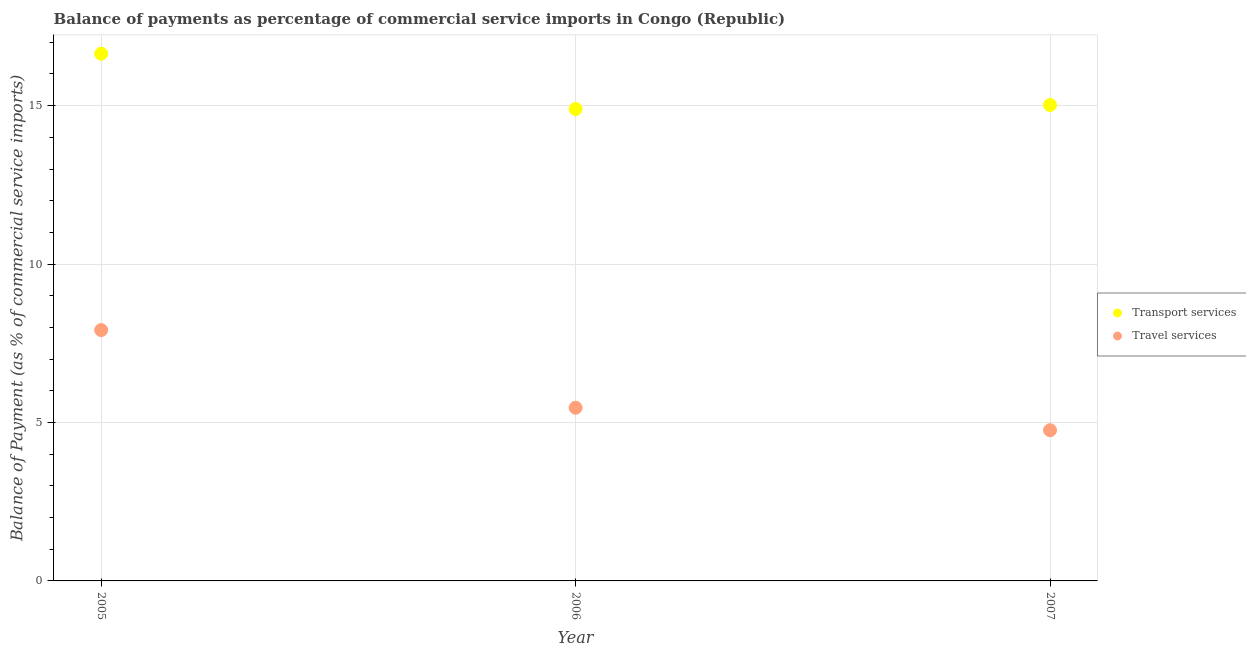What is the balance of payments of travel services in 2005?
Keep it short and to the point. 7.92. Across all years, what is the maximum balance of payments of travel services?
Your response must be concise. 7.92. Across all years, what is the minimum balance of payments of travel services?
Keep it short and to the point. 4.76. In which year was the balance of payments of transport services maximum?
Your response must be concise. 2005. What is the total balance of payments of transport services in the graph?
Ensure brevity in your answer.  46.56. What is the difference between the balance of payments of transport services in 2006 and that in 2007?
Ensure brevity in your answer.  -0.13. What is the difference between the balance of payments of transport services in 2007 and the balance of payments of travel services in 2006?
Offer a terse response. 9.56. What is the average balance of payments of travel services per year?
Give a very brief answer. 6.05. In the year 2007, what is the difference between the balance of payments of travel services and balance of payments of transport services?
Your response must be concise. -10.26. What is the ratio of the balance of payments of transport services in 2005 to that in 2006?
Make the answer very short. 1.12. Is the balance of payments of transport services in 2006 less than that in 2007?
Your answer should be compact. Yes. Is the difference between the balance of payments of transport services in 2005 and 2006 greater than the difference between the balance of payments of travel services in 2005 and 2006?
Provide a succinct answer. No. What is the difference between the highest and the second highest balance of payments of transport services?
Offer a terse response. 1.62. What is the difference between the highest and the lowest balance of payments of transport services?
Keep it short and to the point. 1.74. Is the sum of the balance of payments of travel services in 2005 and 2006 greater than the maximum balance of payments of transport services across all years?
Give a very brief answer. No. Does the balance of payments of transport services monotonically increase over the years?
Your response must be concise. No. Is the balance of payments of transport services strictly less than the balance of payments of travel services over the years?
Your response must be concise. No. What is the difference between two consecutive major ticks on the Y-axis?
Ensure brevity in your answer.  5. Are the values on the major ticks of Y-axis written in scientific E-notation?
Ensure brevity in your answer.  No. What is the title of the graph?
Your answer should be very brief. Balance of payments as percentage of commercial service imports in Congo (Republic). Does "Secondary school" appear as one of the legend labels in the graph?
Keep it short and to the point. No. What is the label or title of the Y-axis?
Provide a short and direct response. Balance of Payment (as % of commercial service imports). What is the Balance of Payment (as % of commercial service imports) of Transport services in 2005?
Keep it short and to the point. 16.64. What is the Balance of Payment (as % of commercial service imports) in Travel services in 2005?
Give a very brief answer. 7.92. What is the Balance of Payment (as % of commercial service imports) of Transport services in 2006?
Your answer should be compact. 14.89. What is the Balance of Payment (as % of commercial service imports) of Travel services in 2006?
Offer a terse response. 5.47. What is the Balance of Payment (as % of commercial service imports) of Transport services in 2007?
Ensure brevity in your answer.  15.02. What is the Balance of Payment (as % of commercial service imports) of Travel services in 2007?
Keep it short and to the point. 4.76. Across all years, what is the maximum Balance of Payment (as % of commercial service imports) of Transport services?
Ensure brevity in your answer.  16.64. Across all years, what is the maximum Balance of Payment (as % of commercial service imports) in Travel services?
Offer a very short reply. 7.92. Across all years, what is the minimum Balance of Payment (as % of commercial service imports) in Transport services?
Offer a very short reply. 14.89. Across all years, what is the minimum Balance of Payment (as % of commercial service imports) of Travel services?
Your answer should be very brief. 4.76. What is the total Balance of Payment (as % of commercial service imports) of Transport services in the graph?
Your response must be concise. 46.56. What is the total Balance of Payment (as % of commercial service imports) of Travel services in the graph?
Your answer should be very brief. 18.14. What is the difference between the Balance of Payment (as % of commercial service imports) of Transport services in 2005 and that in 2006?
Ensure brevity in your answer.  1.74. What is the difference between the Balance of Payment (as % of commercial service imports) of Travel services in 2005 and that in 2006?
Give a very brief answer. 2.45. What is the difference between the Balance of Payment (as % of commercial service imports) in Transport services in 2005 and that in 2007?
Your answer should be very brief. 1.62. What is the difference between the Balance of Payment (as % of commercial service imports) of Travel services in 2005 and that in 2007?
Keep it short and to the point. 3.16. What is the difference between the Balance of Payment (as % of commercial service imports) in Transport services in 2006 and that in 2007?
Give a very brief answer. -0.13. What is the difference between the Balance of Payment (as % of commercial service imports) of Travel services in 2006 and that in 2007?
Your response must be concise. 0.71. What is the difference between the Balance of Payment (as % of commercial service imports) in Transport services in 2005 and the Balance of Payment (as % of commercial service imports) in Travel services in 2006?
Ensure brevity in your answer.  11.17. What is the difference between the Balance of Payment (as % of commercial service imports) of Transport services in 2005 and the Balance of Payment (as % of commercial service imports) of Travel services in 2007?
Give a very brief answer. 11.88. What is the difference between the Balance of Payment (as % of commercial service imports) in Transport services in 2006 and the Balance of Payment (as % of commercial service imports) in Travel services in 2007?
Your answer should be very brief. 10.14. What is the average Balance of Payment (as % of commercial service imports) of Transport services per year?
Your answer should be compact. 15.52. What is the average Balance of Payment (as % of commercial service imports) in Travel services per year?
Keep it short and to the point. 6.05. In the year 2005, what is the difference between the Balance of Payment (as % of commercial service imports) in Transport services and Balance of Payment (as % of commercial service imports) in Travel services?
Your response must be concise. 8.72. In the year 2006, what is the difference between the Balance of Payment (as % of commercial service imports) of Transport services and Balance of Payment (as % of commercial service imports) of Travel services?
Offer a terse response. 9.43. In the year 2007, what is the difference between the Balance of Payment (as % of commercial service imports) of Transport services and Balance of Payment (as % of commercial service imports) of Travel services?
Your answer should be very brief. 10.26. What is the ratio of the Balance of Payment (as % of commercial service imports) in Transport services in 2005 to that in 2006?
Your answer should be very brief. 1.12. What is the ratio of the Balance of Payment (as % of commercial service imports) in Travel services in 2005 to that in 2006?
Provide a short and direct response. 1.45. What is the ratio of the Balance of Payment (as % of commercial service imports) of Transport services in 2005 to that in 2007?
Make the answer very short. 1.11. What is the ratio of the Balance of Payment (as % of commercial service imports) in Travel services in 2005 to that in 2007?
Ensure brevity in your answer.  1.66. What is the ratio of the Balance of Payment (as % of commercial service imports) in Transport services in 2006 to that in 2007?
Offer a very short reply. 0.99. What is the ratio of the Balance of Payment (as % of commercial service imports) of Travel services in 2006 to that in 2007?
Your response must be concise. 1.15. What is the difference between the highest and the second highest Balance of Payment (as % of commercial service imports) in Transport services?
Make the answer very short. 1.62. What is the difference between the highest and the second highest Balance of Payment (as % of commercial service imports) of Travel services?
Keep it short and to the point. 2.45. What is the difference between the highest and the lowest Balance of Payment (as % of commercial service imports) of Transport services?
Ensure brevity in your answer.  1.74. What is the difference between the highest and the lowest Balance of Payment (as % of commercial service imports) of Travel services?
Your response must be concise. 3.16. 